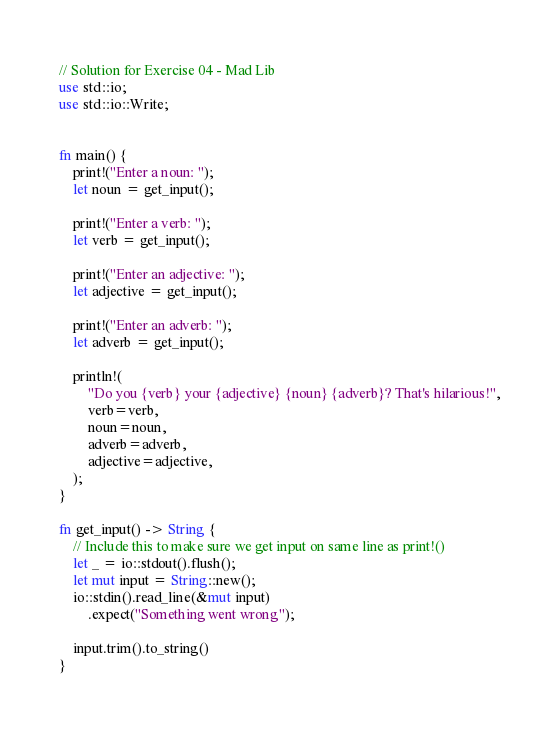<code> <loc_0><loc_0><loc_500><loc_500><_Rust_>// Solution for Exercise 04 - Mad Lib
use std::io;
use std::io::Write;


fn main() {
    print!("Enter a noun: ");
    let noun = get_input();

    print!("Enter a verb: ");
    let verb = get_input();

    print!("Enter an adjective: ");
    let adjective = get_input();

    print!("Enter an adverb: ");
    let adverb = get_input();

    println!(
        "Do you {verb} your {adjective} {noun} {adverb}? That's hilarious!",
        verb=verb,
        noun=noun,
        adverb=adverb,
        adjective=adjective,
    );
}

fn get_input() -> String {
    // Include this to make sure we get input on same line as print!()
    let _ = io::stdout().flush();
    let mut input = String::new();
    io::stdin().read_line(&mut input)
        .expect("Something went wrong");

    input.trim().to_string()
}
</code> 